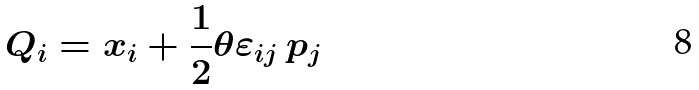<formula> <loc_0><loc_0><loc_500><loc_500>Q _ { i } = x _ { i } + \frac { 1 } { 2 } \theta \varepsilon _ { i j } \, p _ { j }</formula> 